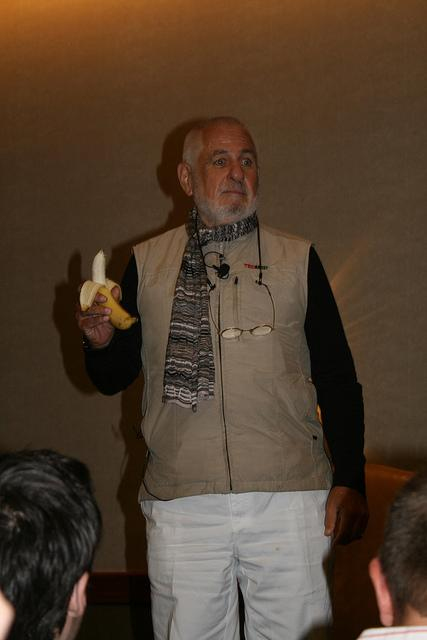What type of eyesight does the man standing here have?

Choices:
A) 2020
B) near sighted
C) perfect
D) far sighted far sighted 